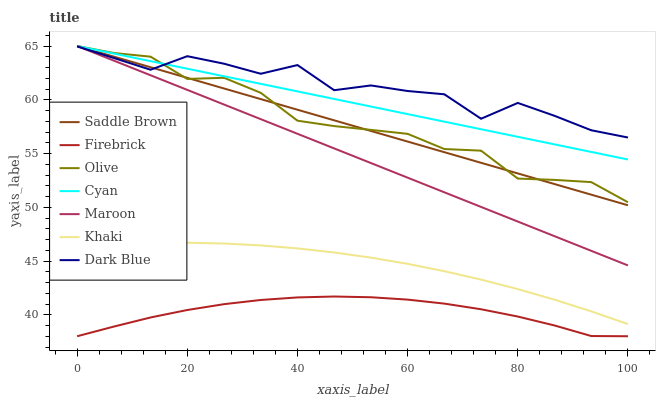Does Firebrick have the minimum area under the curve?
Answer yes or no. Yes. Does Dark Blue have the maximum area under the curve?
Answer yes or no. Yes. Does Maroon have the minimum area under the curve?
Answer yes or no. No. Does Maroon have the maximum area under the curve?
Answer yes or no. No. Is Maroon the smoothest?
Answer yes or no. Yes. Is Dark Blue the roughest?
Answer yes or no. Yes. Is Firebrick the smoothest?
Answer yes or no. No. Is Firebrick the roughest?
Answer yes or no. No. Does Firebrick have the lowest value?
Answer yes or no. Yes. Does Maroon have the lowest value?
Answer yes or no. No. Does Saddle Brown have the highest value?
Answer yes or no. Yes. Does Firebrick have the highest value?
Answer yes or no. No. Is Khaki less than Dark Blue?
Answer yes or no. Yes. Is Olive greater than Khaki?
Answer yes or no. Yes. Does Dark Blue intersect Maroon?
Answer yes or no. Yes. Is Dark Blue less than Maroon?
Answer yes or no. No. Is Dark Blue greater than Maroon?
Answer yes or no. No. Does Khaki intersect Dark Blue?
Answer yes or no. No. 